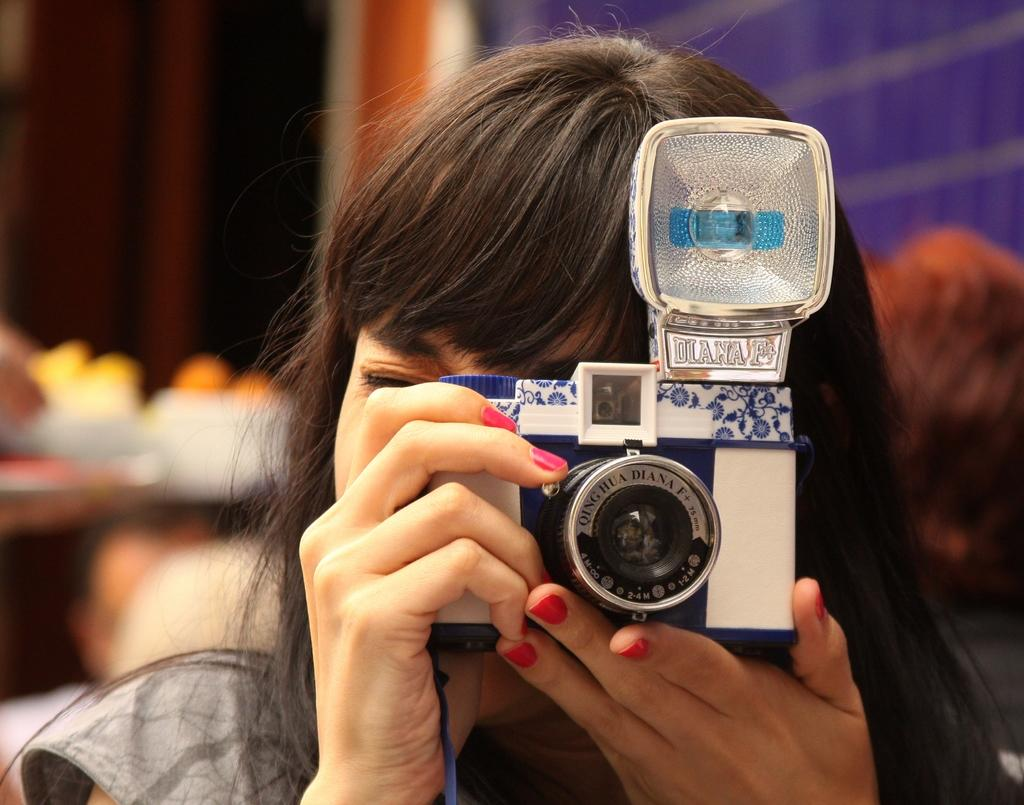<image>
Share a concise interpretation of the image provided. A woman with a camera taking a photo, the camera says Diana F on it in silver 